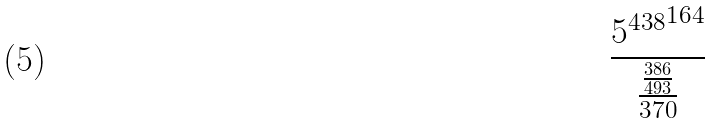Convert formula to latex. <formula><loc_0><loc_0><loc_500><loc_500>\frac { { 5 ^ { 4 3 8 } } ^ { 1 6 4 } } { \frac { \frac { 3 8 6 } { 4 9 3 } } { 3 7 0 } }</formula> 